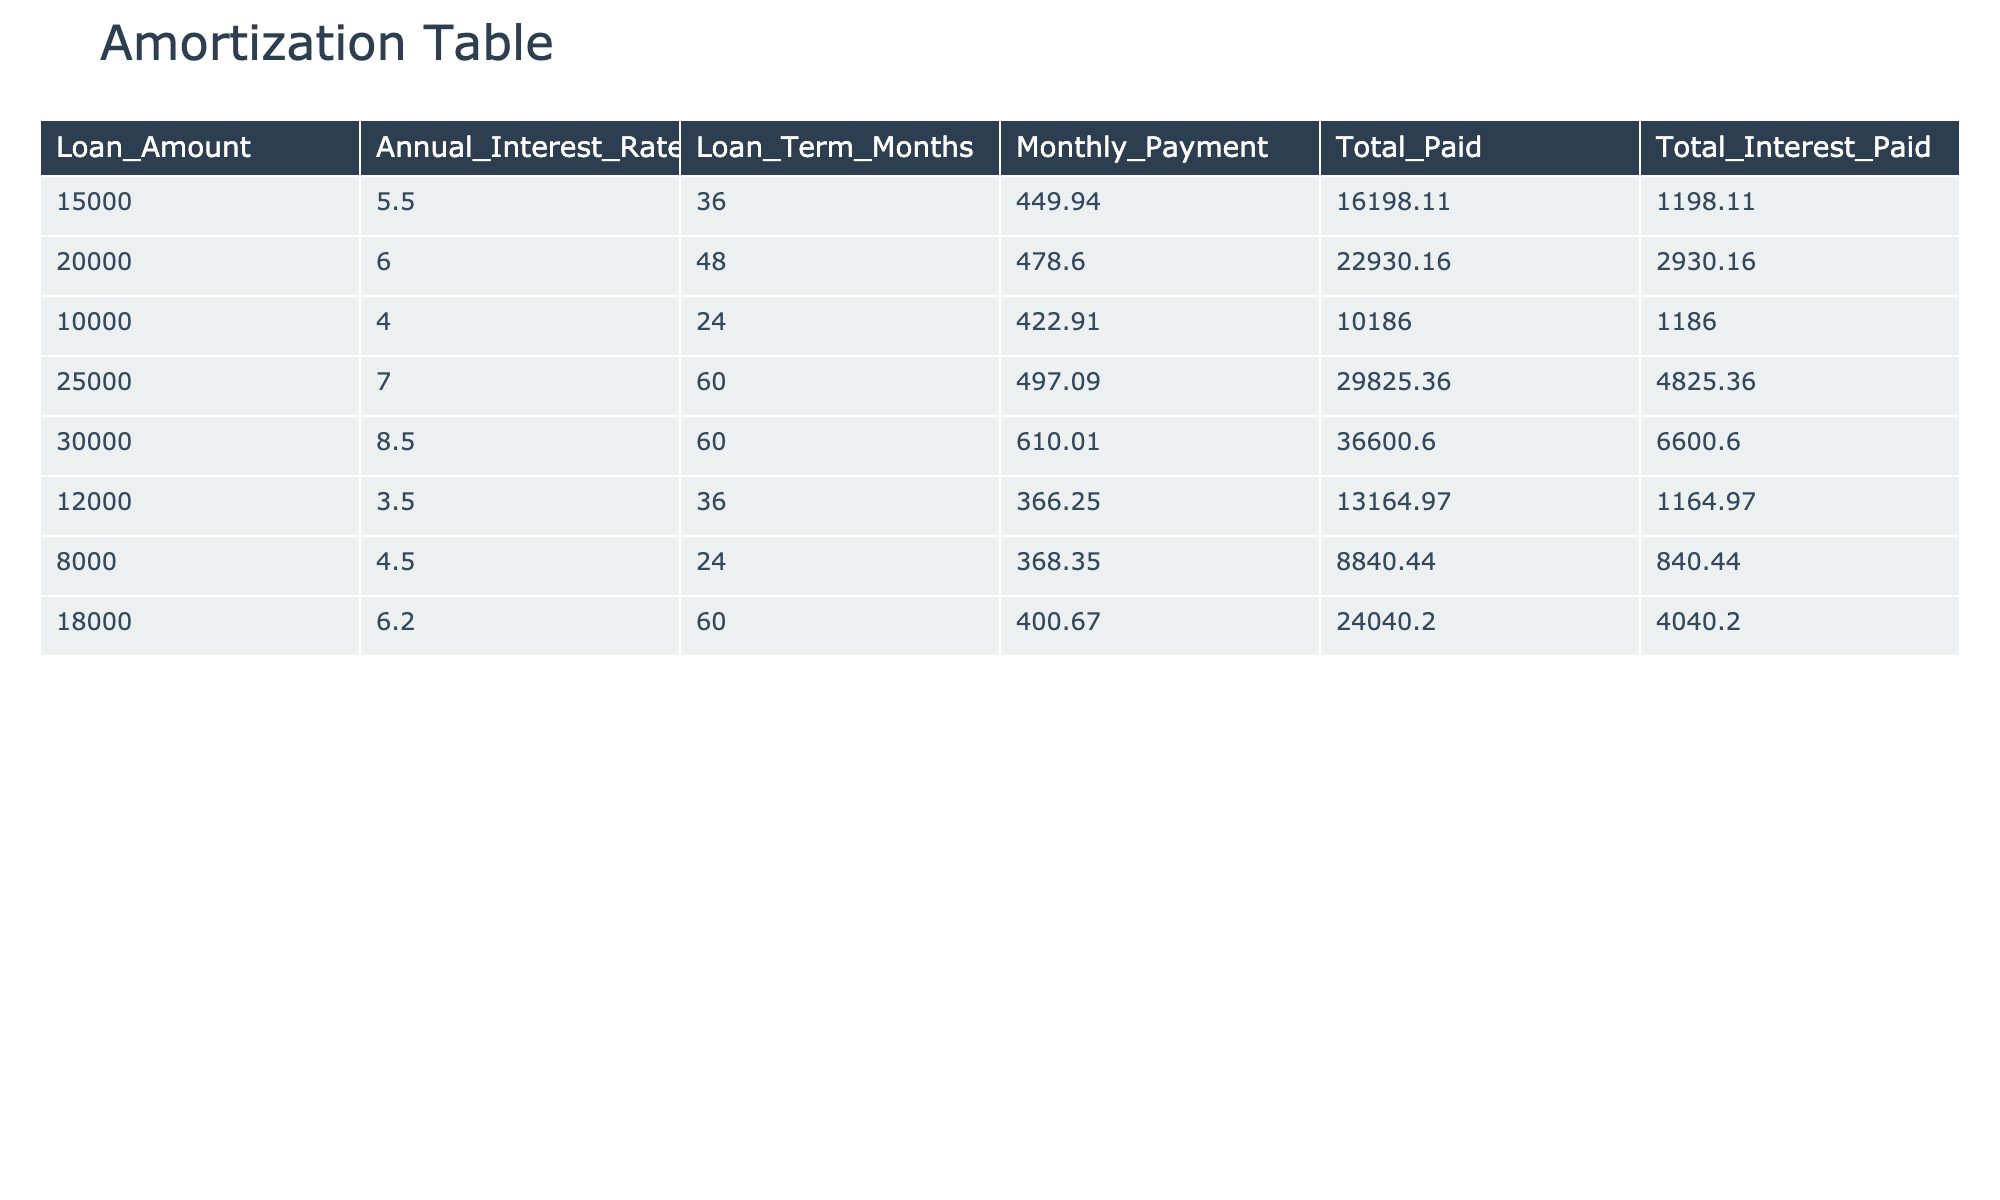What is the highest total interest paid among the loans? The highest total interest paid is from the loan with a total interest of 6600.60. Looking at the total interest paid column, 6600.60 is the highest value.
Answer: 6600.60 Which loan has the lowest monthly payment? The loan with the lowest monthly payment is the one for 8000 at 368.35. By examining the monthly payment column, 368.35 is the smallest figure.
Answer: 368.35 What is the total amount paid for the 20000 loan? The total amount paid for the 20000 loan is 22930.16. This is obtained directly from the total paid column corresponding to the 20000 entry.
Answer: 22930.16 Is the total interest paid for 12000 loan greater than that for 10000 loan? No, the total interest paid for the 12000 loan is 1164.97, whereas the total interest for the 10000 loan is 1186.00. Comparing these two values, 1164.97 is less than 1186.00.
Answer: No What is the average monthly payment for all loans? To find the average monthly payment, sum all the monthly payments (449.94 + 478.60 + 422.91 + 497.09 + 610.01 + 366.25 + 368.35 + 400.67) which equals  3263.82 and divide by the number of loans, which is 8. Thus, the average monthly payment is 3263.82/8 = 407.98.
Answer: 407.98 Which loans have a total paid amount exceeding 30,000? Only the loan of 25000 has a total paid amount of 29825.36, which does not exceed 30,000, while the loan of 30000 has a total paid amount of 36600.60, which does exceed 30,000. Therefore, only the loan of 30000 fits this criterion.
Answer: 30000 loan What is the difference in total paid between the 18000 loan and the 15000 loan? The total paid for the 18000 loan is 24040.20, while for the 15000 loan it is 16198.11. The difference is 24040.20 - 16198.11 = 7832.09. Thus, the difference in total paid is 7832.09.
Answer: 7832.09 Are there any loans with an annual interest rate lower than 4%? No, all loans have an annual interest rate of 4% or higher. Reviewing the annual interest rate column shows that the lowest is 3.5, which is present only for the 12000 loan.
Answer: No 